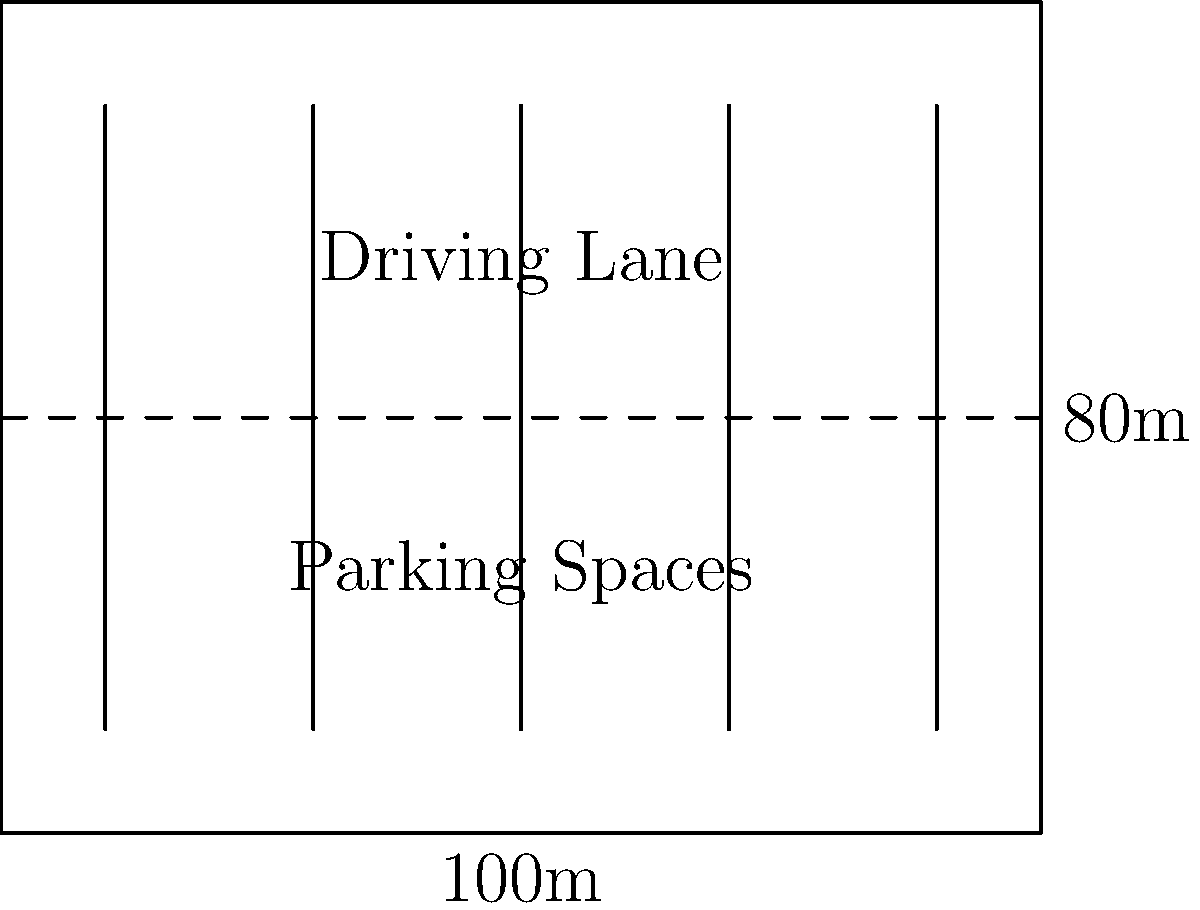A new restaurant is planning its parking lot layout. The available area is rectangular, measuring 100m by 80m. The owner wants to maximize the number of parking spaces while ensuring efficient traffic flow. Each parking space requires 2.5m width and 5m length, with a 6m wide driving lane between rows of spaces. What is the maximum number of parking spaces that can be accommodated in this lot? Let's approach this step-by-step:

1. First, we need to determine how many rows of parking spaces we can fit in the 80m width:
   - Each row requires: 5m (space length) + 6m (driving lane) = 11m
   - Number of rows = $\lfloor 80 \div 11 \rfloor = 7$ rows (using floor division)
   - Remaining space: $80 - (7 \times 11) = 3m$ (can be used for landscaping or walkways)

2. Now, let's calculate how many spaces can fit in each row along the 100m length:
   - Each space requires 2.5m width
   - Number of spaces per row = $\lfloor 100 \div 2.5 \rfloor = 40$ spaces

3. Calculate the total number of parking spaces:
   - Total spaces = Number of rows × Spaces per row
   - Total spaces = $7 \times 40 = 280$ spaces

4. This layout efficiently uses the available space while maintaining proper traffic flow with driving lanes between each row of parking spaces.

5. The remaining 3m width can be used for additional features like pedestrian walkways or landscaping, enhancing the overall design of the parking lot.
Answer: 280 parking spaces 